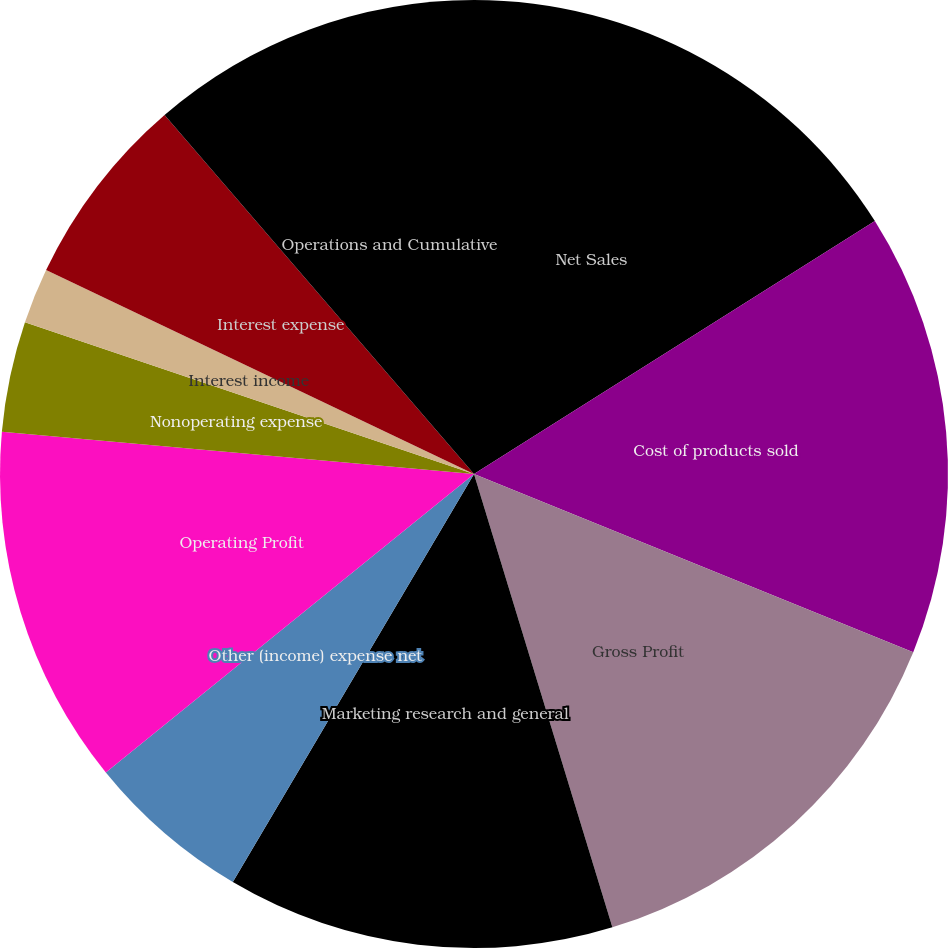<chart> <loc_0><loc_0><loc_500><loc_500><pie_chart><fcel>Net Sales<fcel>Cost of products sold<fcel>Gross Profit<fcel>Marketing research and general<fcel>Other (income) expense net<fcel>Operating Profit<fcel>Nonoperating expense<fcel>Interest income<fcel>Interest expense<fcel>Operations and Cumulative<nl><fcel>16.04%<fcel>15.09%<fcel>14.15%<fcel>13.21%<fcel>5.66%<fcel>12.26%<fcel>3.77%<fcel>1.89%<fcel>6.6%<fcel>11.32%<nl></chart> 